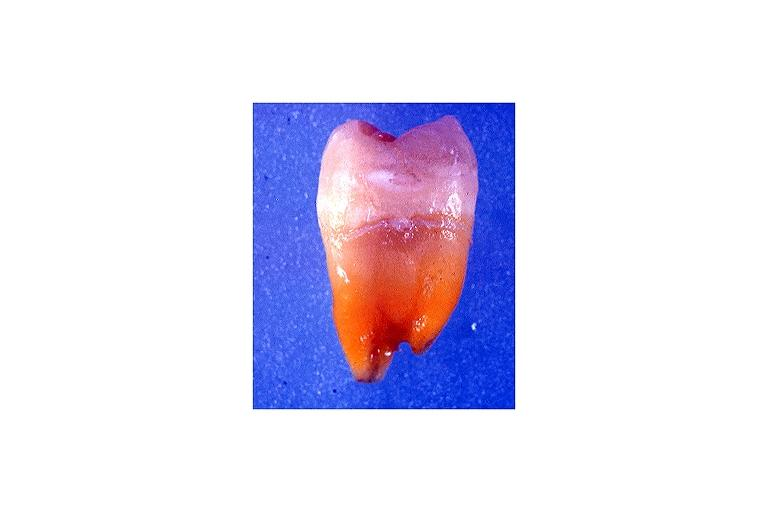s tetracycline induced discoloration?
Answer the question using a single word or phrase. Yes 